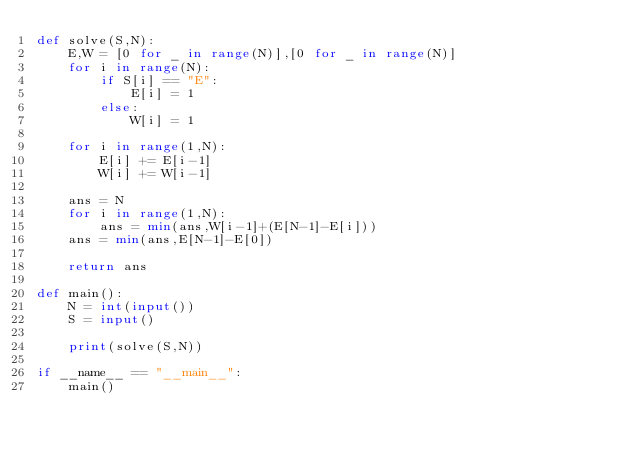<code> <loc_0><loc_0><loc_500><loc_500><_Python_>def solve(S,N):
    E,W = [0 for _ in range(N)],[0 for _ in range(N)]
    for i in range(N):
        if S[i] == "E":
            E[i] = 1
        else:
            W[i] = 1

    for i in range(1,N):
        E[i] += E[i-1]
        W[i] += W[i-1]

    ans = N
    for i in range(1,N):
        ans = min(ans,W[i-1]+(E[N-1]-E[i]))
    ans = min(ans,E[N-1]-E[0])

    return ans

def main():
    N = int(input())
    S = input()

    print(solve(S,N))

if __name__ == "__main__":
    main()
</code> 